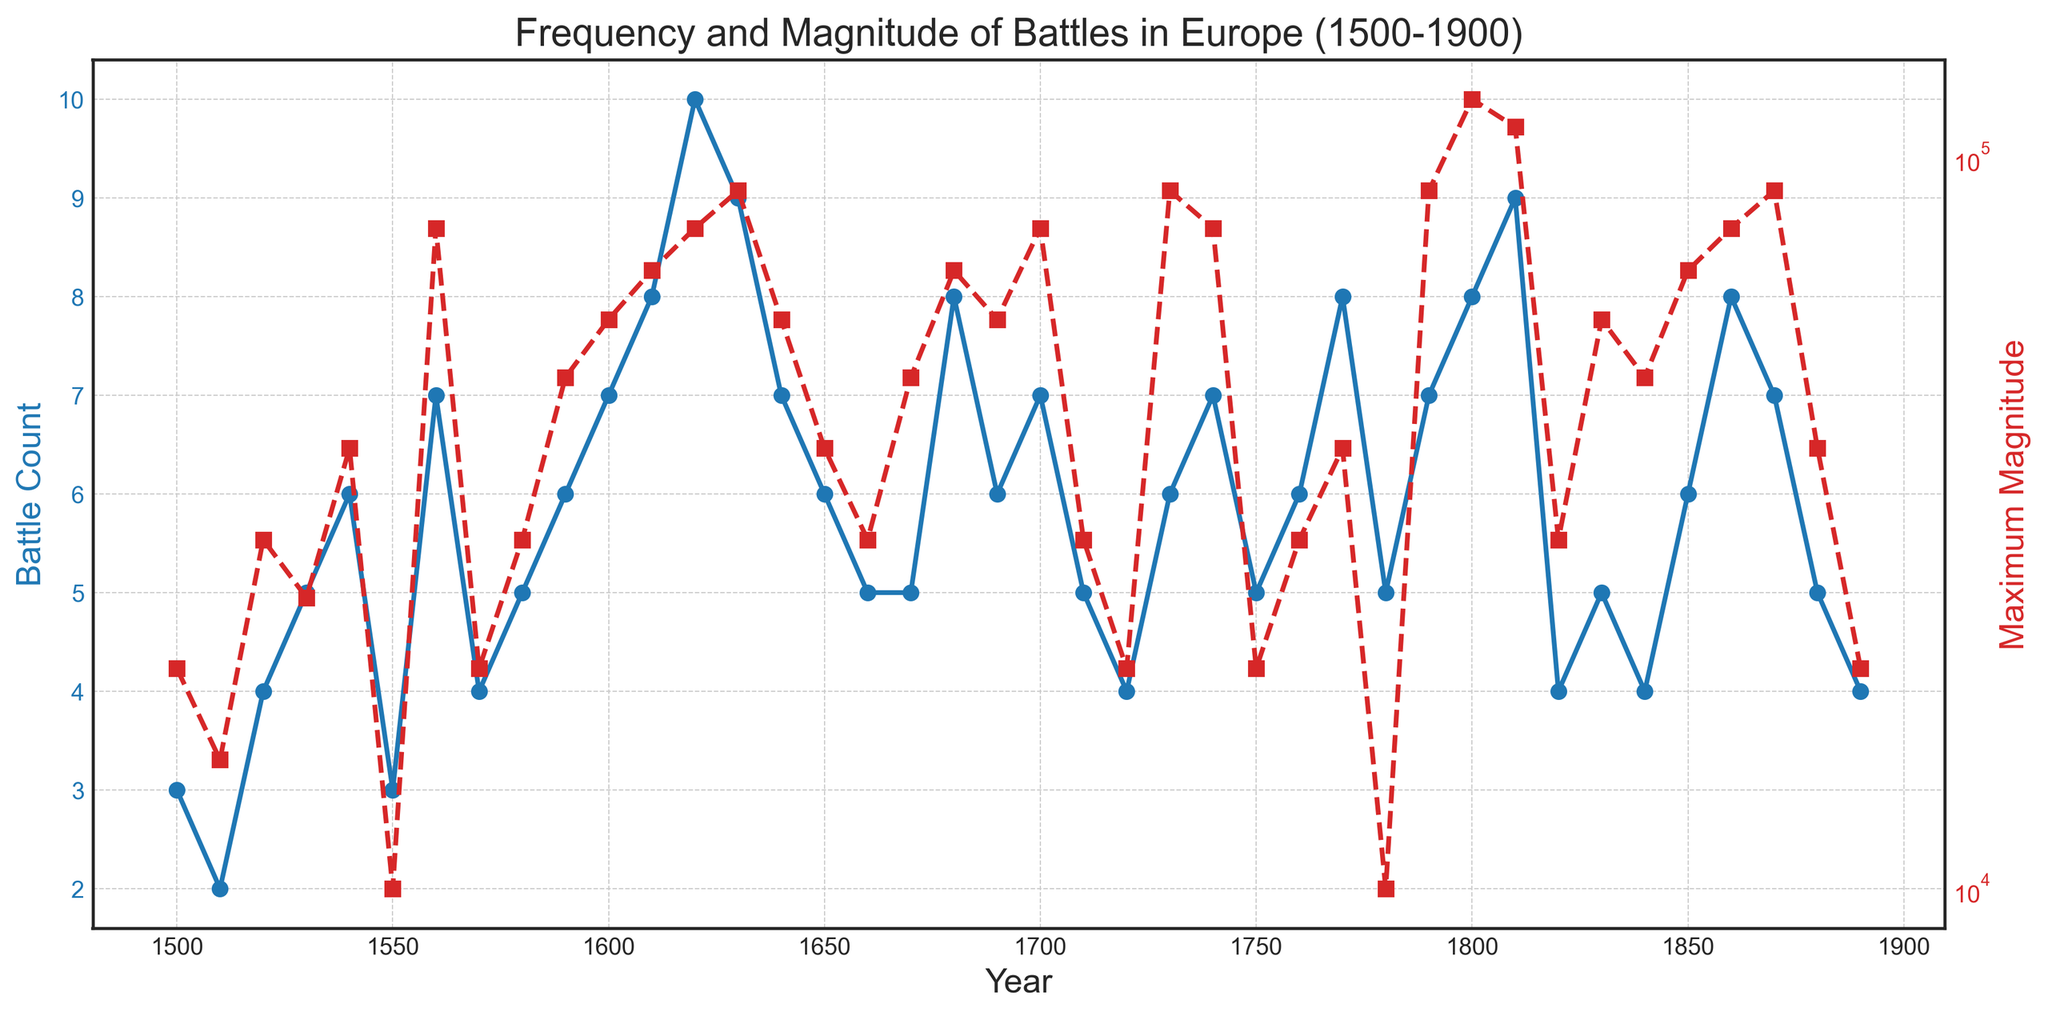What's the trend of battle counts over the years 1600 to 1700? To determine the trend, observe the blue line representing battle counts between 1600 and 1700. From 1600 to 1700, the battle count fluctuates but remains roughly between 5 to 10, indicating a relatively stable trend.
Answer: Stable During which decade did the maximum magnitude of battles reach its highest value, and what was that value? Look at the red line indicating maximum magnitudes on the log scale. The highest point is in the decade of 1800, where the maximum magnitude is 120,000.
Answer: 1800s, 120000 How many battles occurred in the 1560s, and what was the maximum magnitude in that decade? Find the year 1560, which falls in the 1560s, on the x-axis. The battle count is indicated by the blue line and the maximum magnitude by the red line. In the 1560s, there were 7 battles, and the maximum magnitude was 80,000.
Answer: 7 battles, 80000 What is the average battle count from 1590 to 1610 inclusive? Identify the years 1590, 1600, and 1610. Sum the battle counts for these years (6 + 7 + 8 = 21) and divide by 3 (the number of years). The average battle count is 21/3 = 7.
Answer: 7 Did any decade experience a decline in the maximum magnitude of battles compared to the previous decade, and if so, which one(s)? Compare the red line values for each decade, noting where the line dips. Maximum magnitude declines are observed from 1530 to 1540 (25000 to 10000) and from 1830 to 1840 (60000 to 50000).
Answer: 1530-1540, 1830-1840 Compare the battle counts of the 1680s and 1870s. Which decade had more battles? Check the blue line for the years in the 1680s and 1870s. The 1680s had 8 battles and the 1870s had 7 battles. Therefore, the 1680s had more battles.
Answer: 1680s Which year had the lowest battle count, and what was the corresponding maximum magnitude? Scan the blue line to find the lowest point. The year 1510 had the lowest battle count with 2 battles, and the corresponding maximum magnitude was 15000.
Answer: 1510, 15000 What years experienced a maximum magnitude of 90000? Look at the red line for the value 90000 on the y-axis. The years with a 90000 maximum magnitude are 1630, 1730, 1790, and 1870.
Answer: 1630, 1730, 1790, 1870 Was there any year where the battle count exceeded 8, and if so, which year(s)? Check the blue line for values greater than 8. The year 1620, with 10 battle counts, had more than 8 battles.
Answer: 1620 